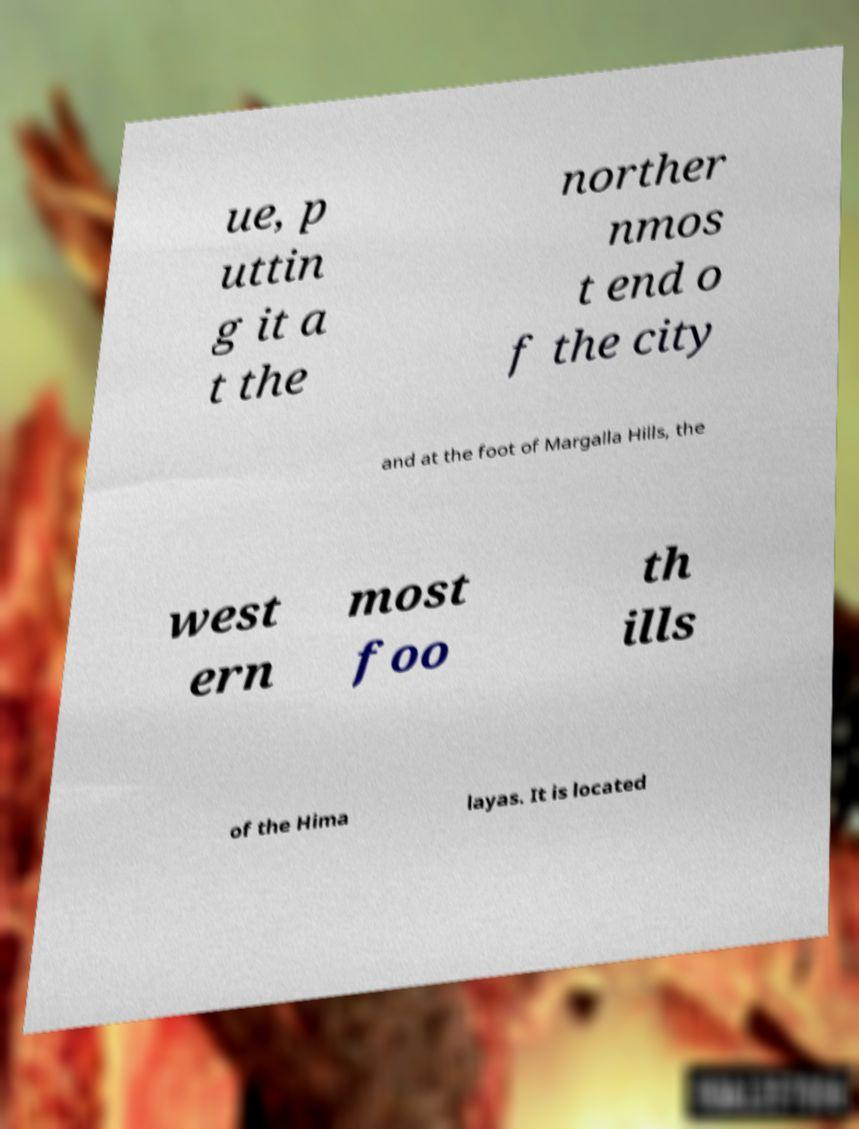Can you accurately transcribe the text from the provided image for me? ue, p uttin g it a t the norther nmos t end o f the city and at the foot of Margalla Hills, the west ern most foo th ills of the Hima layas. It is located 